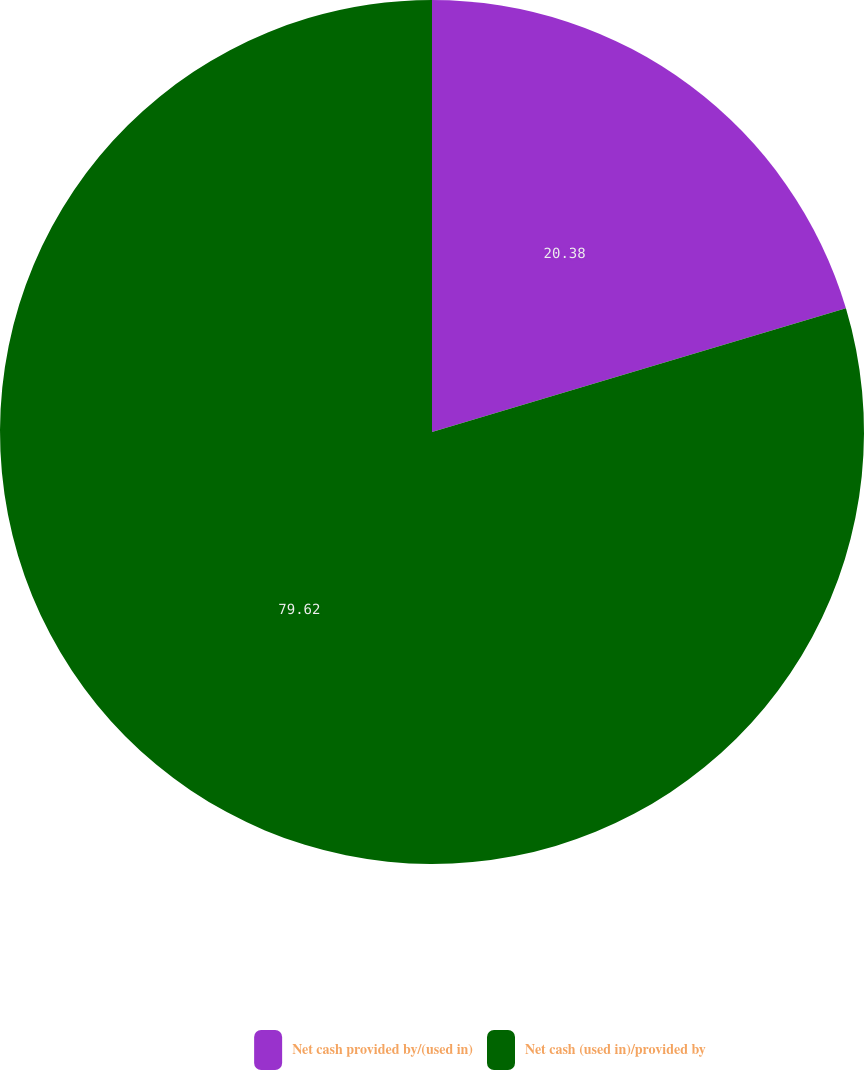Convert chart to OTSL. <chart><loc_0><loc_0><loc_500><loc_500><pie_chart><fcel>Net cash provided by/(used in)<fcel>Net cash (used in)/provided by<nl><fcel>20.38%<fcel>79.62%<nl></chart> 